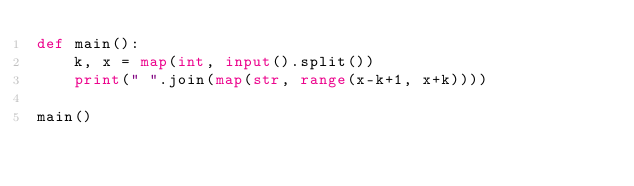<code> <loc_0><loc_0><loc_500><loc_500><_Python_>def main():
    k, x = map(int, input().split())
    print(" ".join(map(str, range(x-k+1, x+k))))

main()
</code> 